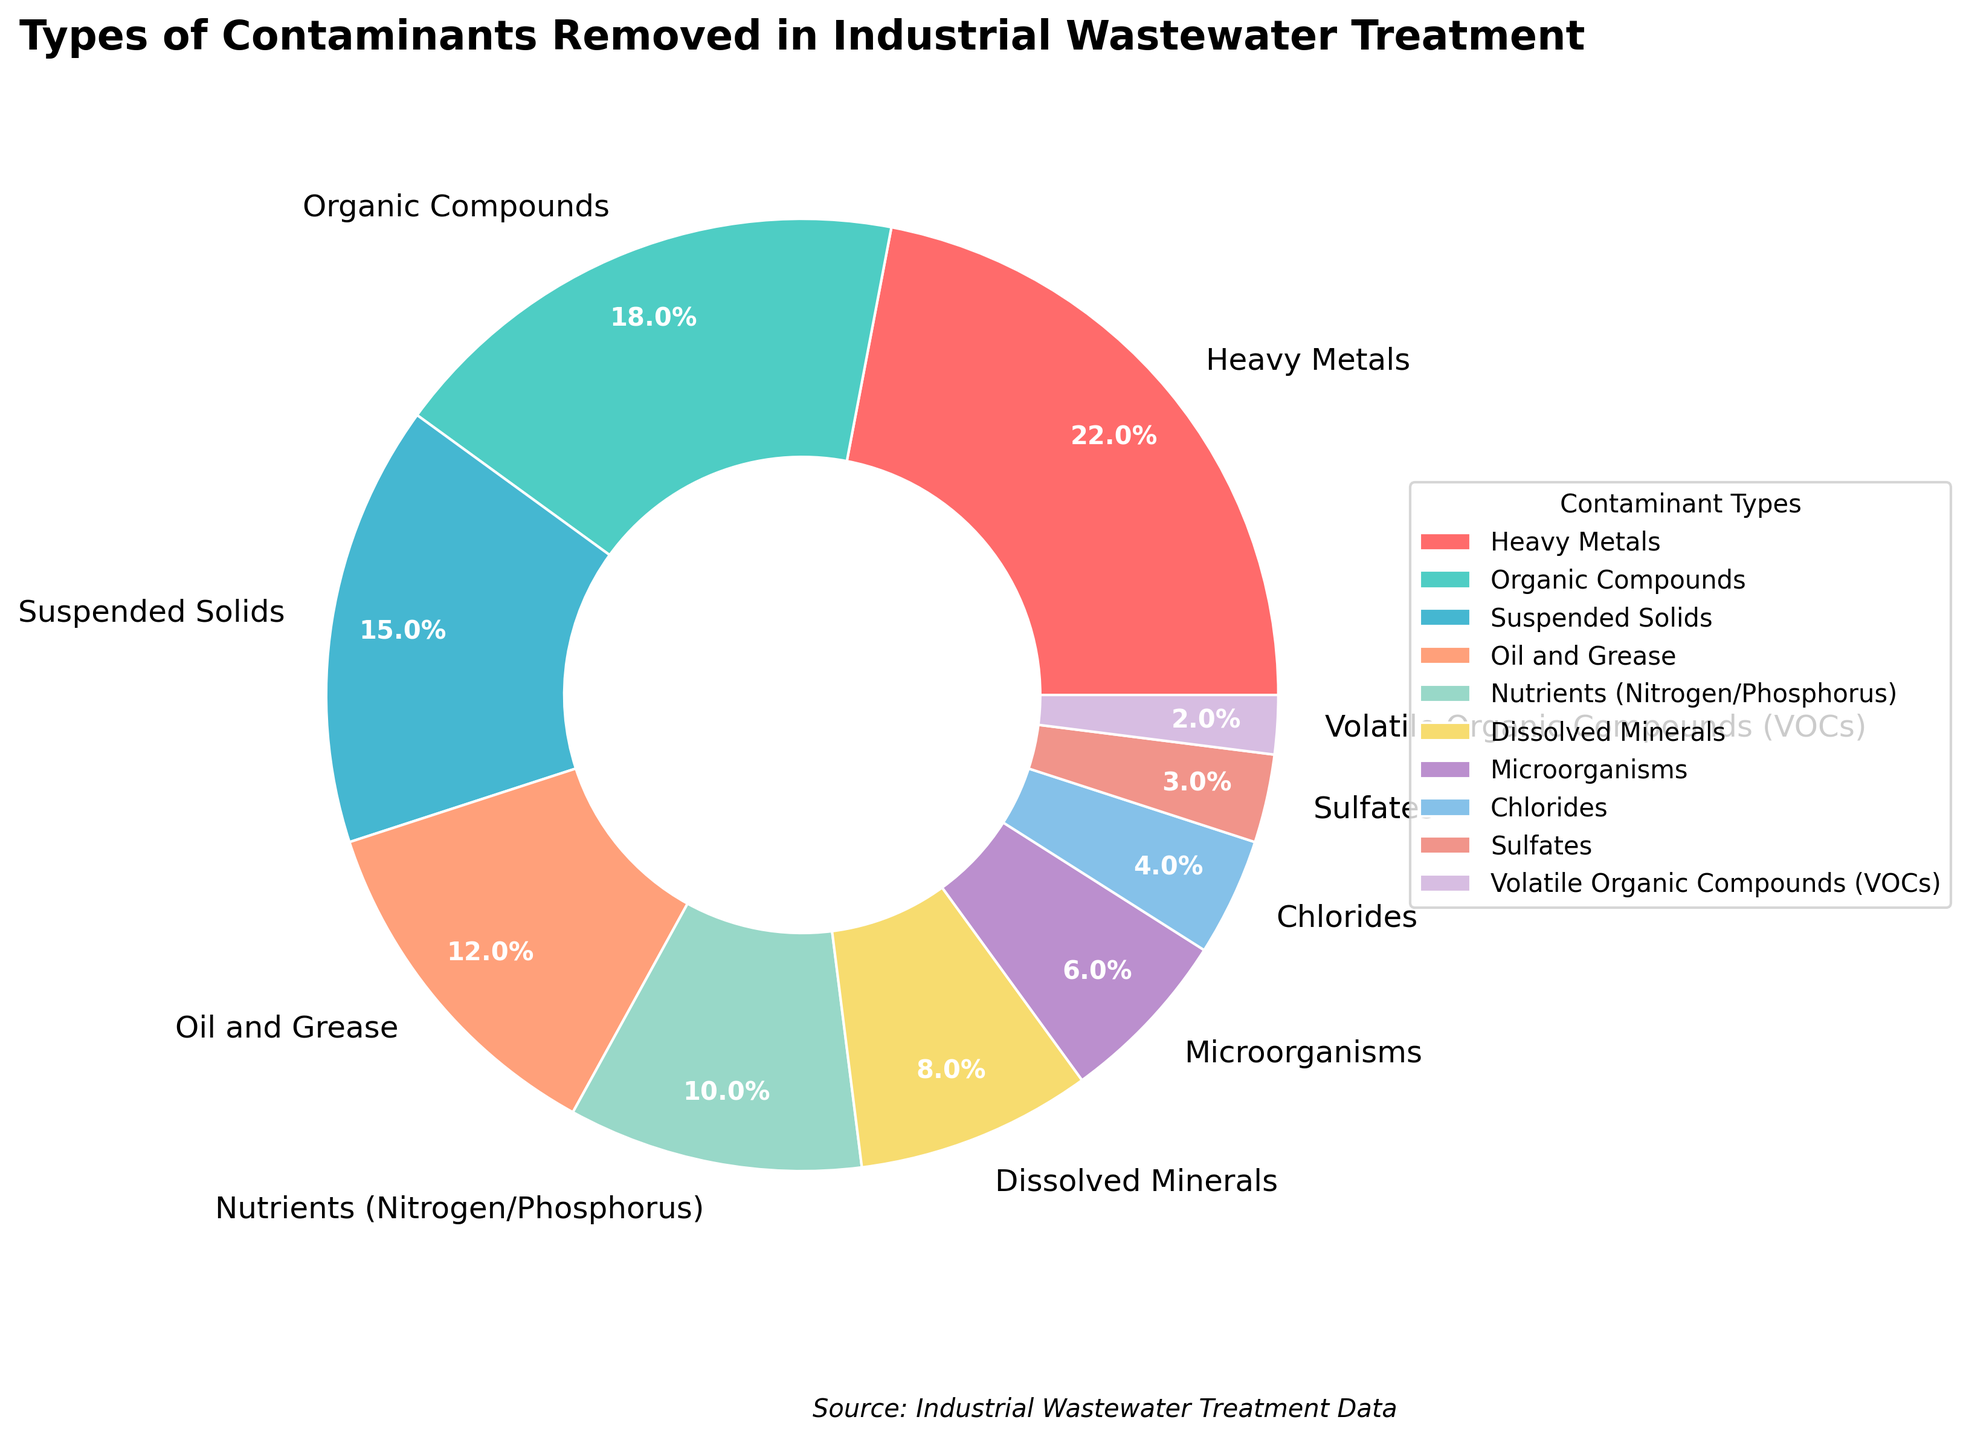What is the largest type of contaminant removed in industrial wastewater treatment? The largest type of contaminant removed can be identified by looking at the segment with the highest percentage. The Heavy Metals segment represents 22%, which is the largest.
Answer: Heavy Metals What is the combined percentage of Oil and Grease, and Nutrients (Nitrogen/Phosphorus)? To find the combined percentage, add the percentages of Oil and Grease, and Nutrients (Nitrogen/Phosphorus): 12% + 10% = 22%.
Answer: 22% Which contaminant type has a larger percentage removed, Organic Compounds or Microorganisms? Compare the percentages of both data points. Organic Compounds have 18%, while Microorganisms have 6%. Thus, Organic Compounds have a larger percentage removed.
Answer: Organic Compounds How much more percentage of Heavy Metals is removed compared to VOCs? Subtract the percentage of VOCs from Heavy Metals: 22% - 2% = 20%.
Answer: 20% What is the median value of the contaminant percentages? To find the median, list the percentages in order: 2, 3, 4, 6, 8, 10, 12, 15, 18, 22. The median is the middle value of this ordered list, which is (8 + 10)/2 = 9.
Answer: 9 Which contaminant type represents the smallest percentage removed? The smallest segment in the pie chart represents the VOCs, which have a 2% share.
Answer: VOCs What is the total percentage of contaminants removed that are not Heavy Metals or Organic Compounds? Subtract the percentages of Heavy Metals and Organic Compounds from 100%: 100% - (22% + 18%) = 60%.
Answer: 60% Identify the two contaminant types with the closest percentages removed. What are their percentages? The closest percentages to each other are Chlorides (4%) and Sulfates (3%), with a difference of 1%.
Answer: Chlorides (4%), Sulfates (3%) Which three contaminant types together make up more than half of the total pie chart? Add the percentages of the largest segments until the sum exceeds 50%. Heavy Metals (22%) + Organic Compounds (18%) + Suspended Solids (15%) = 55%.
Answer: Heavy Metals, Organic Compounds, Suspended Solids 